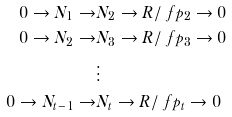<formula> <loc_0><loc_0><loc_500><loc_500>0 \rightarrow N _ { 1 } \rightarrow & N _ { 2 } \rightarrow R / \ f p _ { 2 } \rightarrow 0 \\ 0 \rightarrow N _ { 2 } \rightarrow & N _ { 3 } \rightarrow R / \ f p _ { 3 } \rightarrow 0 \\ & \vdots \\ 0 \rightarrow N _ { t - 1 } \rightarrow & N _ { t } \rightarrow R / \ f p _ { t } \rightarrow 0</formula> 